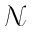<formula> <loc_0><loc_0><loc_500><loc_500>{ \mathcal { N } }</formula> 